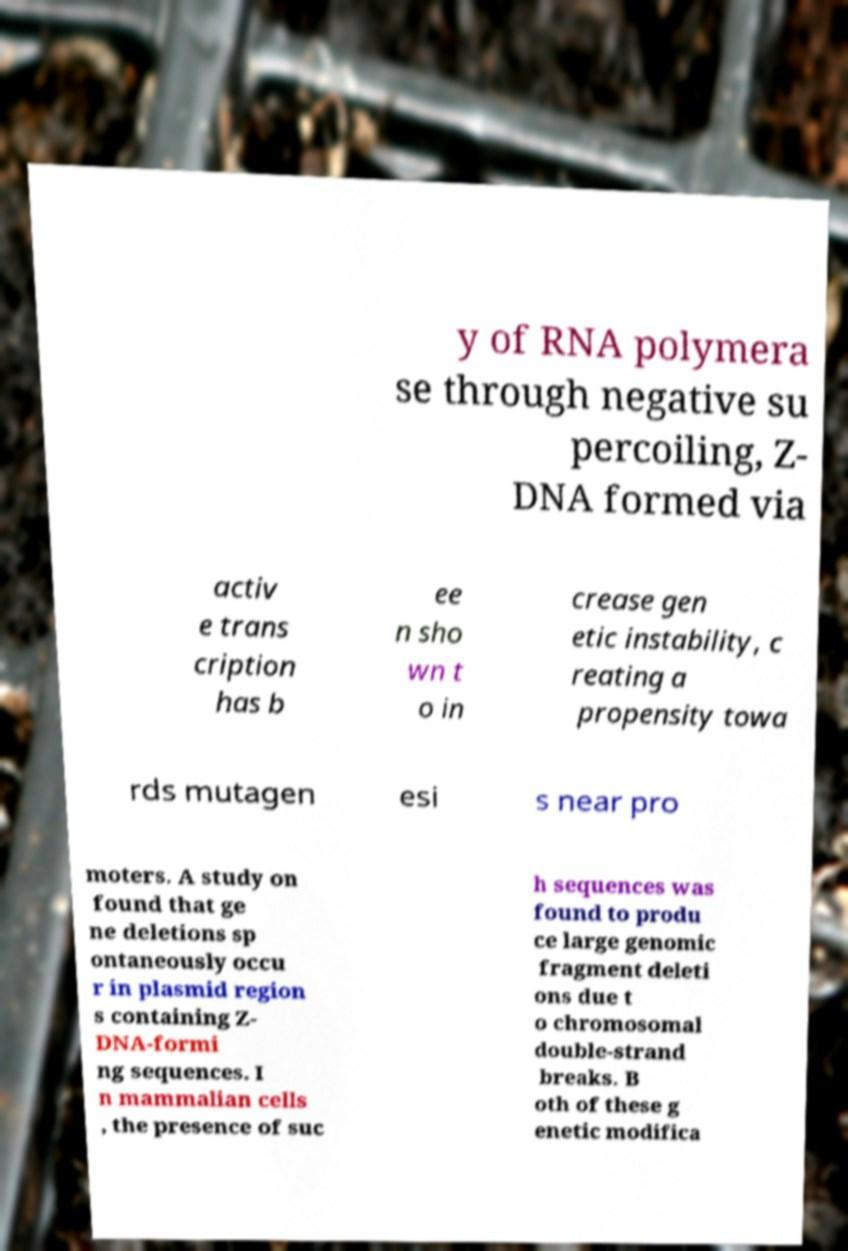There's text embedded in this image that I need extracted. Can you transcribe it verbatim? y of RNA polymera se through negative su percoiling, Z- DNA formed via activ e trans cription has b ee n sho wn t o in crease gen etic instability, c reating a propensity towa rds mutagen esi s near pro moters. A study on found that ge ne deletions sp ontaneously occu r in plasmid region s containing Z- DNA-formi ng sequences. I n mammalian cells , the presence of suc h sequences was found to produ ce large genomic fragment deleti ons due t o chromosomal double-strand breaks. B oth of these g enetic modifica 